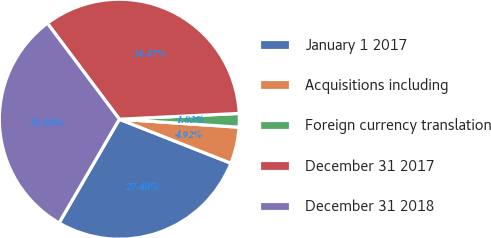Convert chart. <chart><loc_0><loc_0><loc_500><loc_500><pie_chart><fcel>January 1 2017<fcel>Acquisitions including<fcel>Foreign currency translation<fcel>December 31 2017<fcel>December 31 2018<nl><fcel>27.4%<fcel>4.92%<fcel>1.83%<fcel>34.47%<fcel>31.38%<nl></chart> 